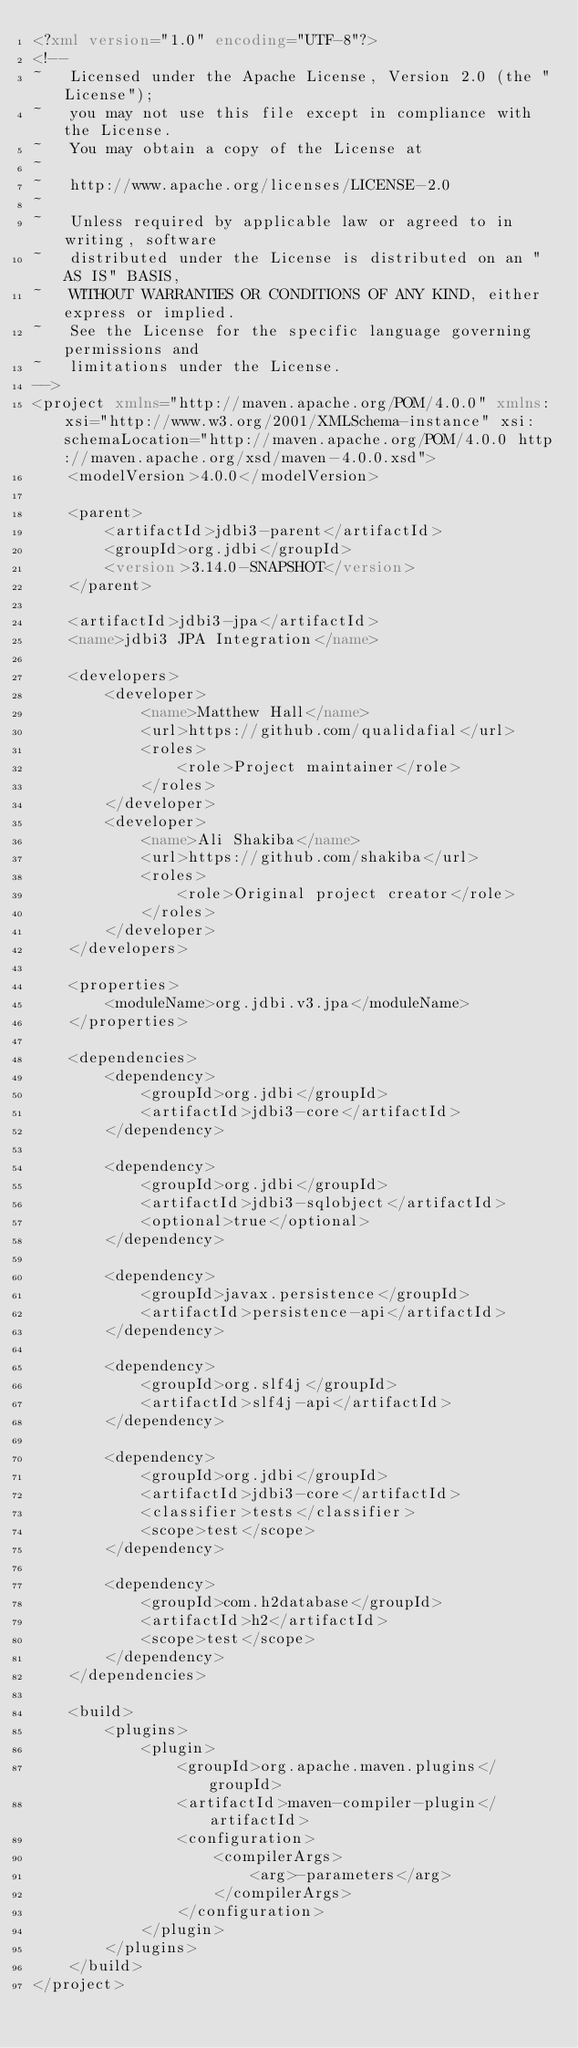Convert code to text. <code><loc_0><loc_0><loc_500><loc_500><_XML_><?xml version="1.0" encoding="UTF-8"?>
<!--
~   Licensed under the Apache License, Version 2.0 (the "License");
~   you may not use this file except in compliance with the License.
~   You may obtain a copy of the License at
~
~   http://www.apache.org/licenses/LICENSE-2.0
~
~   Unless required by applicable law or agreed to in writing, software
~   distributed under the License is distributed on an "AS IS" BASIS,
~   WITHOUT WARRANTIES OR CONDITIONS OF ANY KIND, either express or implied.
~   See the License for the specific language governing permissions and
~   limitations under the License.
-->
<project xmlns="http://maven.apache.org/POM/4.0.0" xmlns:xsi="http://www.w3.org/2001/XMLSchema-instance" xsi:schemaLocation="http://maven.apache.org/POM/4.0.0 http://maven.apache.org/xsd/maven-4.0.0.xsd">
    <modelVersion>4.0.0</modelVersion>

    <parent>
        <artifactId>jdbi3-parent</artifactId>
        <groupId>org.jdbi</groupId>
        <version>3.14.0-SNAPSHOT</version>
    </parent>

    <artifactId>jdbi3-jpa</artifactId>
    <name>jdbi3 JPA Integration</name>

    <developers>
        <developer>
            <name>Matthew Hall</name>
            <url>https://github.com/qualidafial</url>
            <roles>
                <role>Project maintainer</role>
            </roles>
        </developer>
        <developer>
            <name>Ali Shakiba</name>
            <url>https://github.com/shakiba</url>
            <roles>
                <role>Original project creator</role>
            </roles>
        </developer>
    </developers>

    <properties>
        <moduleName>org.jdbi.v3.jpa</moduleName>
    </properties>

    <dependencies>
        <dependency>
            <groupId>org.jdbi</groupId>
            <artifactId>jdbi3-core</artifactId>
        </dependency>

        <dependency>
            <groupId>org.jdbi</groupId>
            <artifactId>jdbi3-sqlobject</artifactId>
            <optional>true</optional>
        </dependency>

        <dependency>
            <groupId>javax.persistence</groupId>
            <artifactId>persistence-api</artifactId>
        </dependency>

        <dependency>
            <groupId>org.slf4j</groupId>
            <artifactId>slf4j-api</artifactId>
        </dependency>

        <dependency>
            <groupId>org.jdbi</groupId>
            <artifactId>jdbi3-core</artifactId>
            <classifier>tests</classifier>
            <scope>test</scope>
        </dependency>

        <dependency>
            <groupId>com.h2database</groupId>
            <artifactId>h2</artifactId>
            <scope>test</scope>
        </dependency>
    </dependencies>

    <build>
        <plugins>
            <plugin>
                <groupId>org.apache.maven.plugins</groupId>
                <artifactId>maven-compiler-plugin</artifactId>
                <configuration>
                    <compilerArgs>
                        <arg>-parameters</arg>
                    </compilerArgs>
                </configuration>
            </plugin>
        </plugins>
    </build>
</project>
</code> 